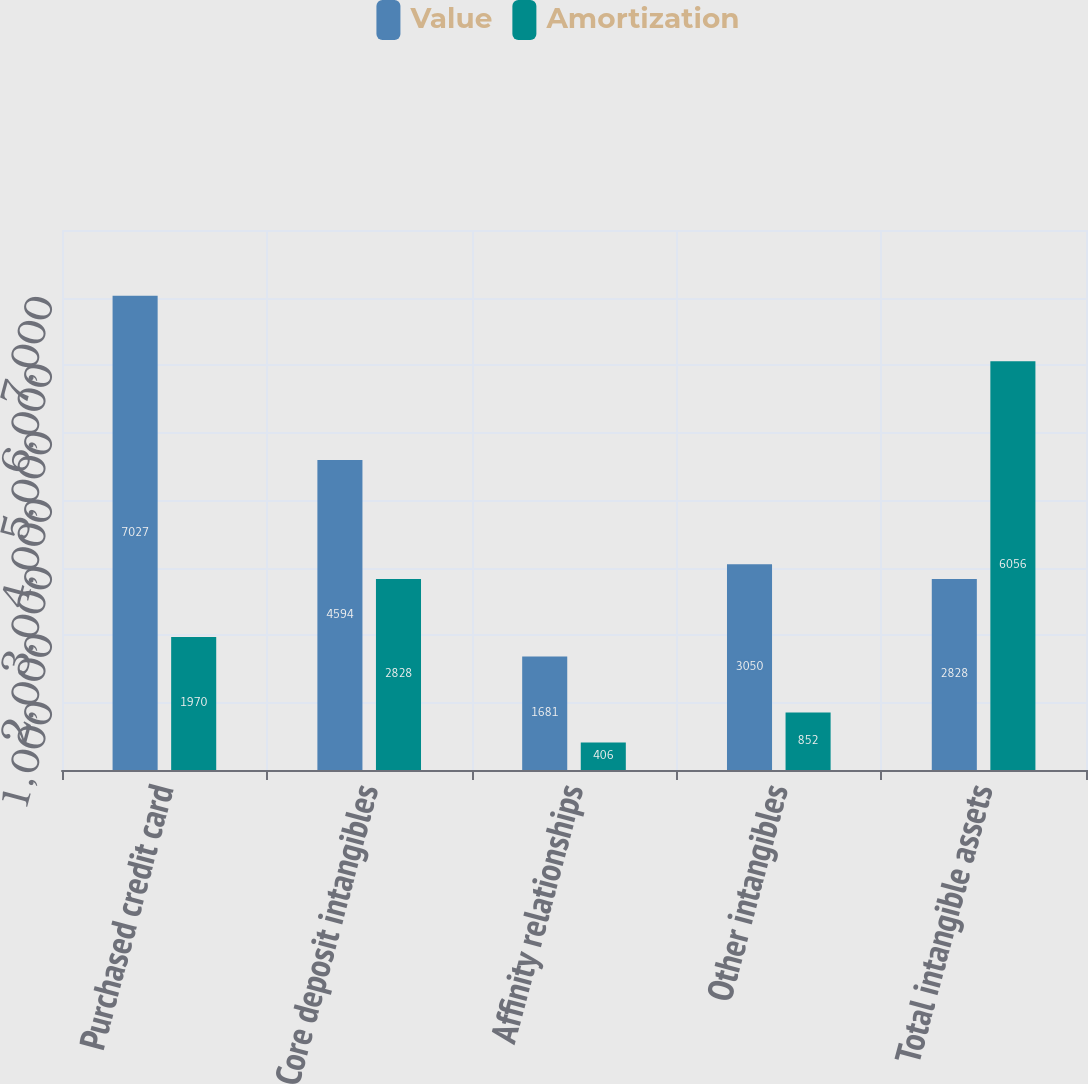Convert chart. <chart><loc_0><loc_0><loc_500><loc_500><stacked_bar_chart><ecel><fcel>Purchased credit card<fcel>Core deposit intangibles<fcel>Affinity relationships<fcel>Other intangibles<fcel>Total intangible assets<nl><fcel>Value<fcel>7027<fcel>4594<fcel>1681<fcel>3050<fcel>2828<nl><fcel>Amortization<fcel>1970<fcel>2828<fcel>406<fcel>852<fcel>6056<nl></chart> 